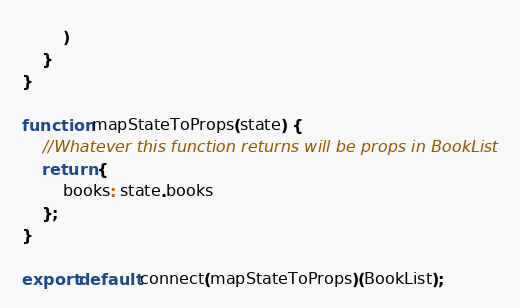Convert code to text. <code><loc_0><loc_0><loc_500><loc_500><_JavaScript_>        )
    }
}

function mapStateToProps(state) {
    //Whatever this function returns will be props in BookList
    return {
        books: state.books
    };
}

export default connect(mapStateToProps)(BookList);</code> 